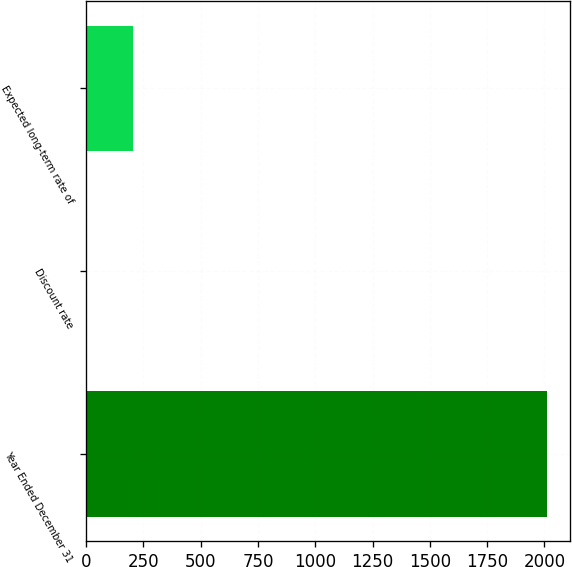<chart> <loc_0><loc_0><loc_500><loc_500><bar_chart><fcel>Year Ended December 31<fcel>Discount rate<fcel>Expected long-term rate of<nl><fcel>2012<fcel>4.75<fcel>205.48<nl></chart> 